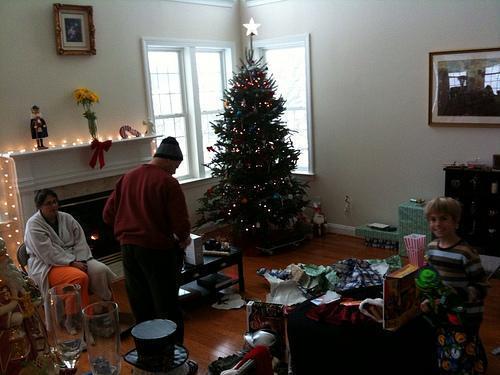How many people are there?
Give a very brief answer. 3. How many people are in the photo?
Give a very brief answer. 3. How many wine glasses are there?
Give a very brief answer. 2. 